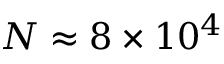<formula> <loc_0><loc_0><loc_500><loc_500>N \approx 8 \times 1 0 ^ { 4 }</formula> 